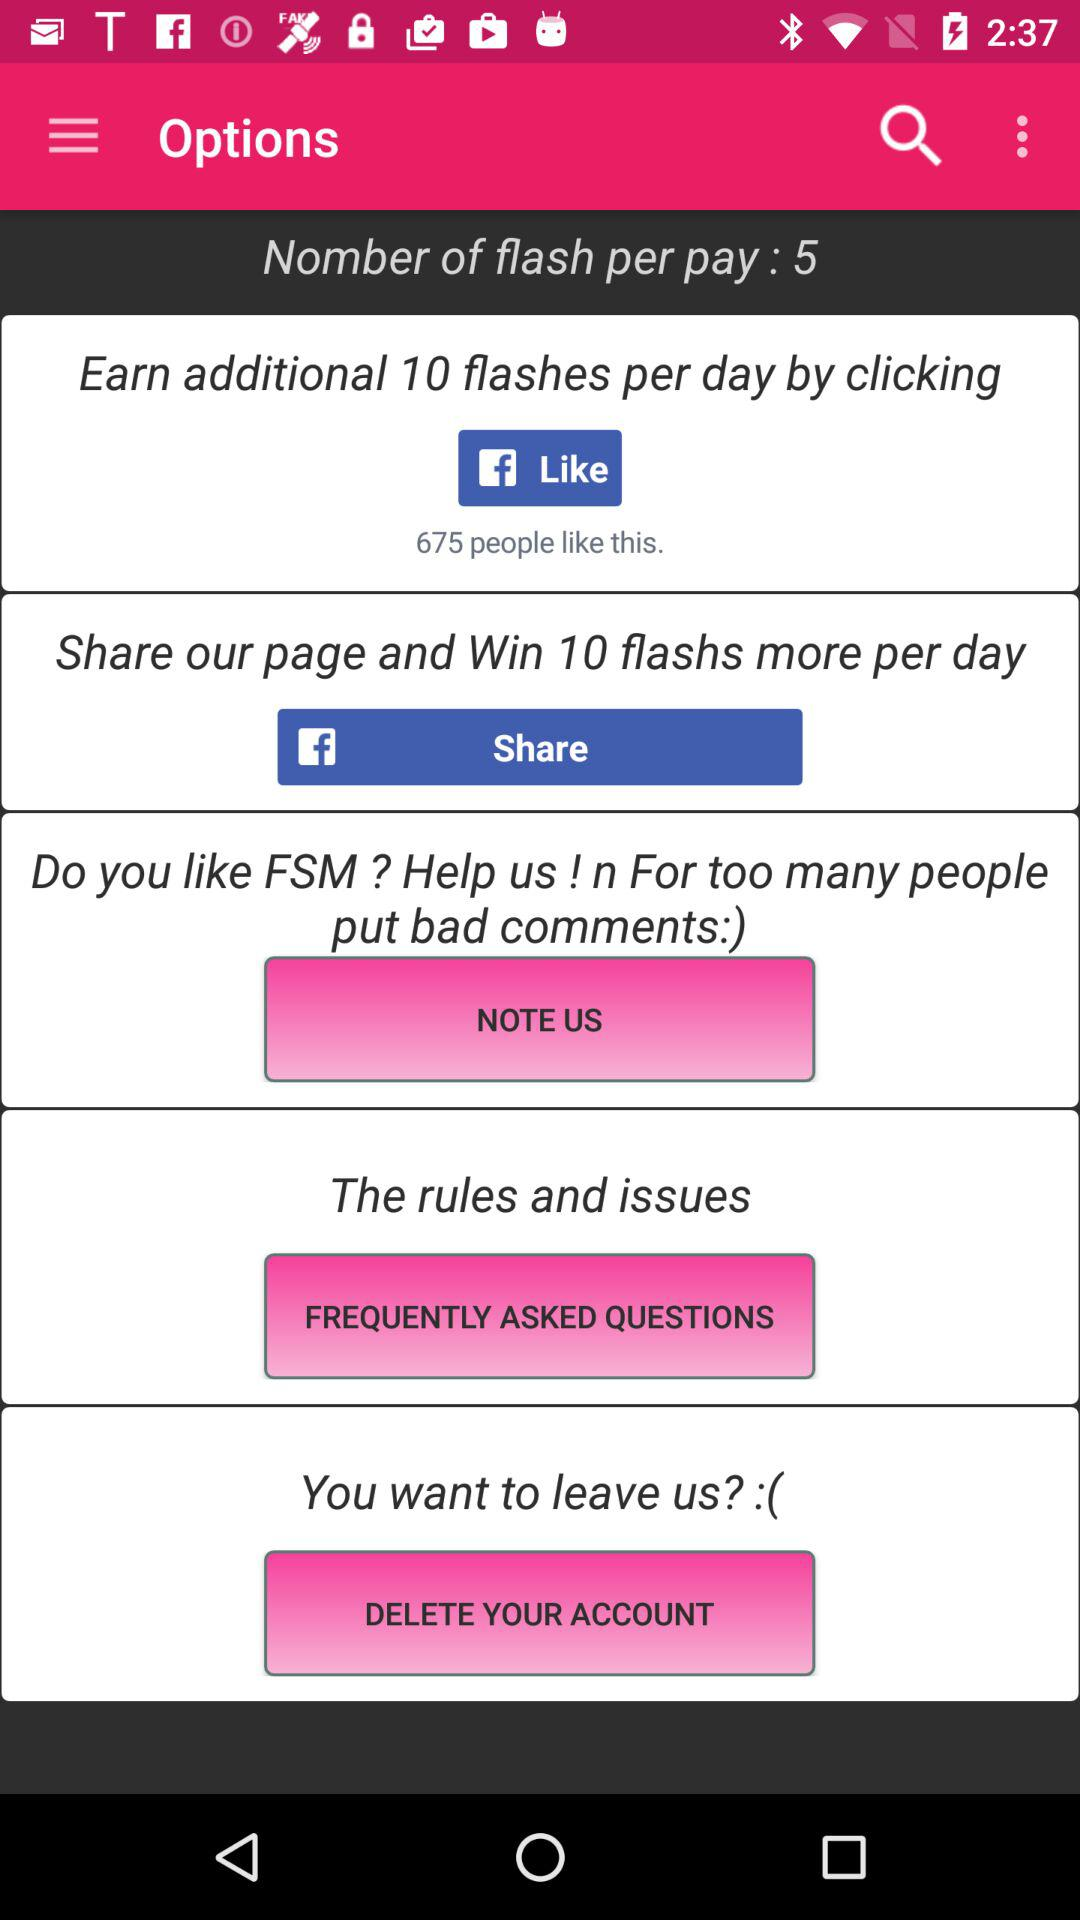How many more flashs can I win if I share the page?
Answer the question using a single word or phrase. 10 